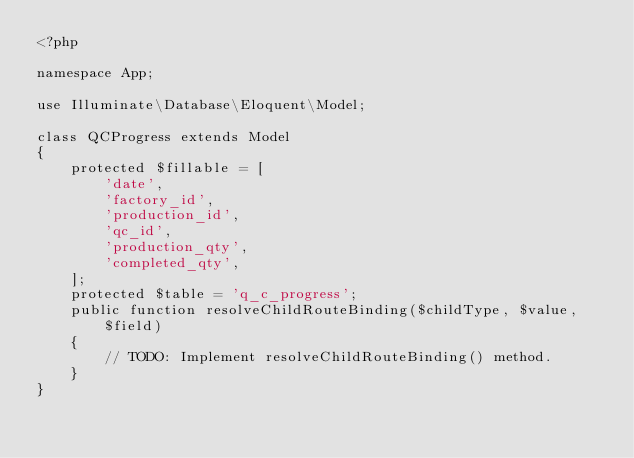<code> <loc_0><loc_0><loc_500><loc_500><_PHP_><?php

namespace App;

use Illuminate\Database\Eloquent\Model;

class QCProgress extends Model
{
    protected $fillable = [
        'date',
        'factory_id',
        'production_id',
        'qc_id',
        'production_qty',
        'completed_qty',
    ];
    protected $table = 'q_c_progress';
    public function resolveChildRouteBinding($childType, $value, $field)
    {
        // TODO: Implement resolveChildRouteBinding() method.
    }
}
</code> 